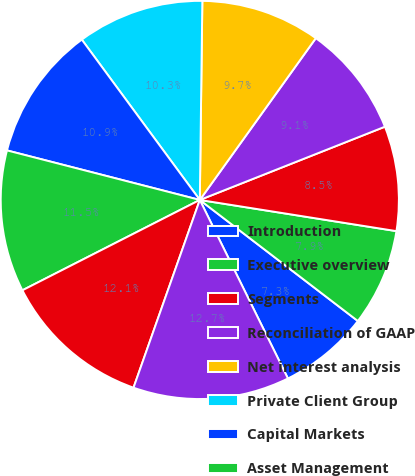Convert chart. <chart><loc_0><loc_0><loc_500><loc_500><pie_chart><fcel>Introduction<fcel>Executive overview<fcel>Segments<fcel>Reconciliation of GAAP<fcel>Net interest analysis<fcel>Private Client Group<fcel>Capital Markets<fcel>Asset Management<fcel>RJ Bank<fcel>Other<nl><fcel>7.3%<fcel>7.9%<fcel>8.5%<fcel>9.1%<fcel>9.7%<fcel>10.3%<fcel>10.9%<fcel>11.5%<fcel>12.1%<fcel>12.7%<nl></chart> 